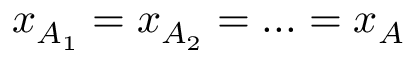Convert formula to latex. <formula><loc_0><loc_0><loc_500><loc_500>x _ { A _ { 1 } } = x _ { A _ { 2 } } = \dots = x _ { A }</formula> 